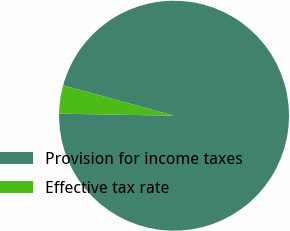Convert chart to OTSL. <chart><loc_0><loc_0><loc_500><loc_500><pie_chart><fcel>Provision for income taxes<fcel>Effective tax rate<nl><fcel>96.03%<fcel>3.97%<nl></chart> 